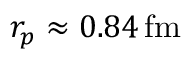<formula> <loc_0><loc_0><loc_500><loc_500>r _ { p } \approx 0 . 8 4 \, f m</formula> 